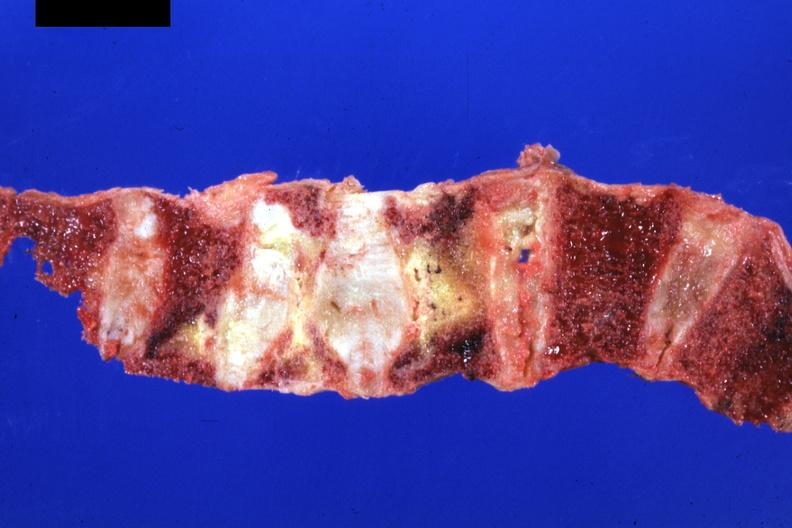what is present?
Answer the question using a single word or phrase. Joints 